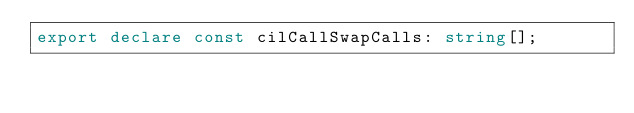Convert code to text. <code><loc_0><loc_0><loc_500><loc_500><_TypeScript_>export declare const cilCallSwapCalls: string[];</code> 